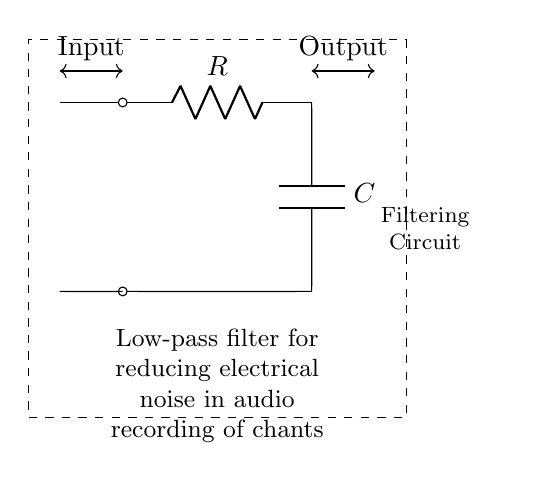What are the components of this circuit? The circuit consists of a resistor and a capacitor, visible as labeled 'R' and 'C' respectively in the diagram.
Answer: Resistor, Capacitor What is the purpose of the circuit? The circuit is designed as a low-pass filter to reduce electrical noise in audio recordings, indicated by the label below the circuit diagram.
Answer: Reducing electrical noise What type of filter is this circuit? The circuit is a low-pass filter, which allows signals with a frequency lower than a certain cutoff frequency to pass and attenuates higher frequencies.
Answer: Low-pass filter What is the output of the circuit? The output is taken from the junction after the capacitor, where the processed signal is provided, clearly indicated as 'Output' in the diagram.
Answer: Output Why is a low-pass filter used in audio recordings? A low-pass filter is used to remove high-frequency noise that can interfere with the clarity of audio recordings, focusing on the desired lower frequencies of chants.
Answer: To remove high-frequency noise What happens to the signal with frequencies above the cutoff? Frequencies above the cutoff frequency are attenuated, meaning their amplitude is reduced significantly, preventing them from appearing in the output signal.
Answer: They are attenuated How does the resistor value affect the filter? The value of the resistor determines the cutoff frequency of the filter; a larger resistance results in a lower cutoff frequency, affecting how much high-frequency noise is filtered out.
Answer: It affects the cutoff frequency 